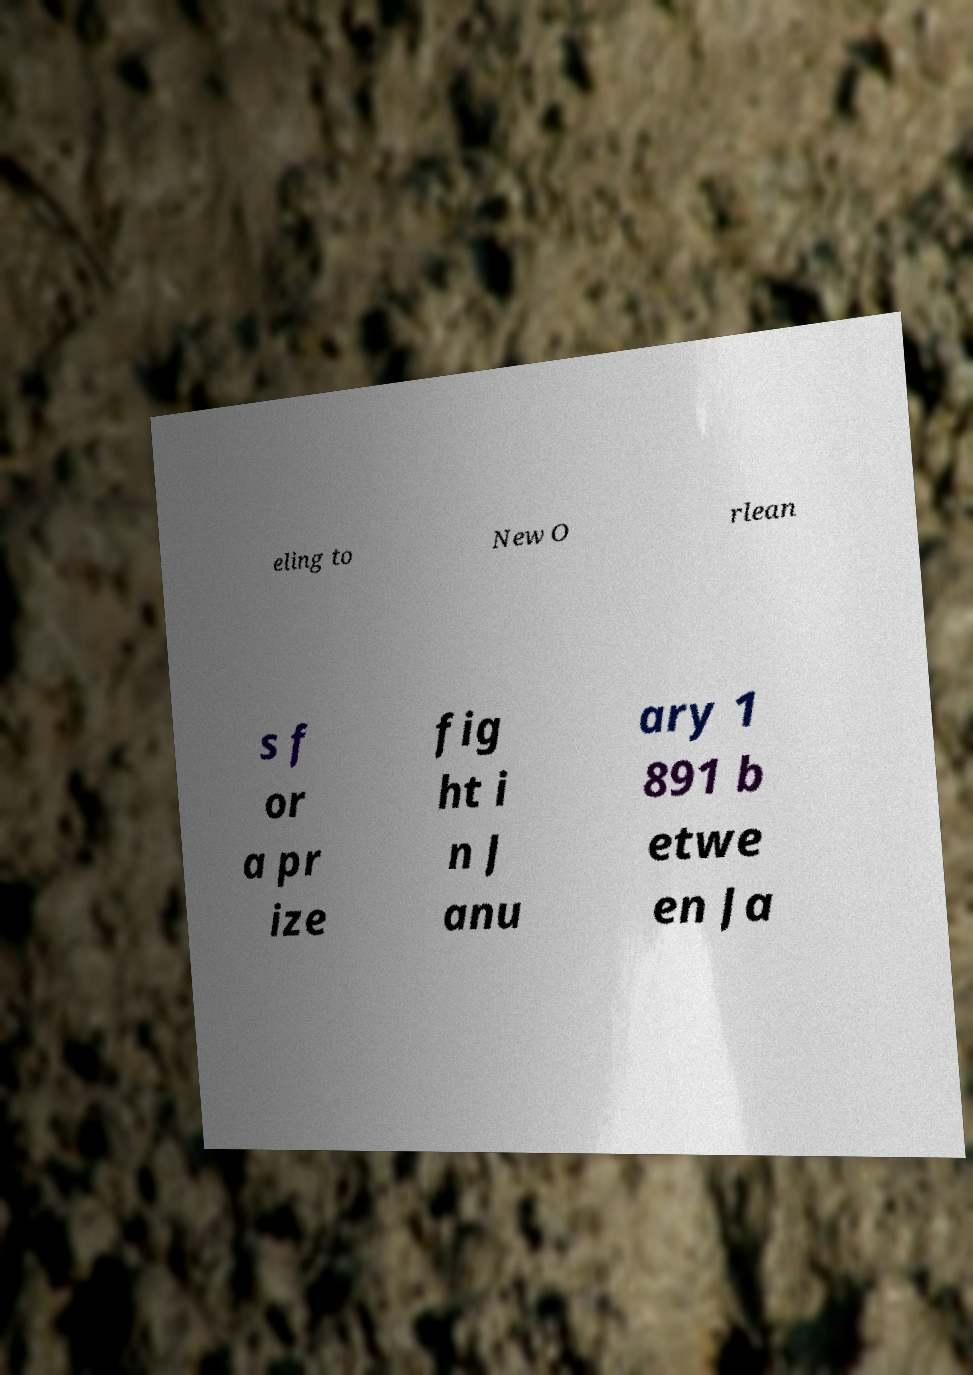Can you read and provide the text displayed in the image?This photo seems to have some interesting text. Can you extract and type it out for me? eling to New O rlean s f or a pr ize fig ht i n J anu ary 1 891 b etwe en Ja 